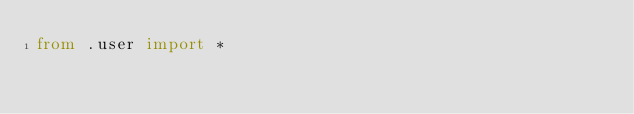<code> <loc_0><loc_0><loc_500><loc_500><_Python_>from .user import *
</code> 